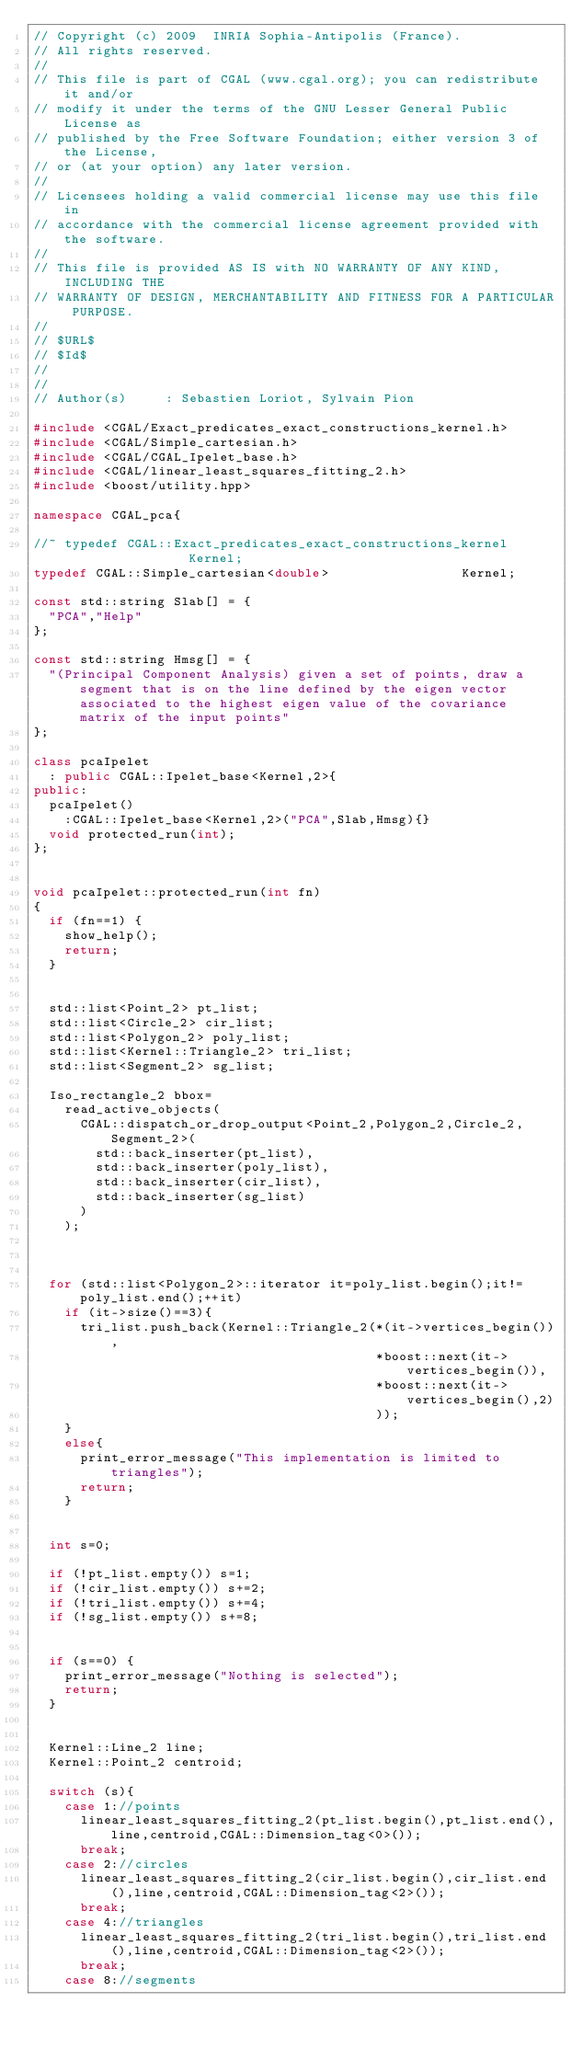Convert code to text. <code><loc_0><loc_0><loc_500><loc_500><_C++_>// Copyright (c) 2009  INRIA Sophia-Antipolis (France).
// All rights reserved.
//
// This file is part of CGAL (www.cgal.org); you can redistribute it and/or
// modify it under the terms of the GNU Lesser General Public License as
// published by the Free Software Foundation; either version 3 of the License,
// or (at your option) any later version.
//
// Licensees holding a valid commercial license may use this file in
// accordance with the commercial license agreement provided with the software.
//
// This file is provided AS IS with NO WARRANTY OF ANY KIND, INCLUDING THE
// WARRANTY OF DESIGN, MERCHANTABILITY AND FITNESS FOR A PARTICULAR PURPOSE.
//
// $URL$
// $Id$
// 
//
// Author(s)     : Sebastien Loriot, Sylvain Pion

#include <CGAL/Exact_predicates_exact_constructions_kernel.h>
#include <CGAL/Simple_cartesian.h>
#include <CGAL/CGAL_Ipelet_base.h> 
#include <CGAL/linear_least_squares_fitting_2.h>
#include <boost/utility.hpp>

namespace CGAL_pca{

//~ typedef CGAL::Exact_predicates_exact_constructions_kernel                 Kernel;
typedef CGAL::Simple_cartesian<double>                 Kernel;
  
const std::string Slab[] = {
  "PCA","Help"
};

const std::string Hmsg[] = {
  "(Principal Component Analysis) given a set of points, draw a segment that is on the line defined by the eigen vector associated to the highest eigen value of the covariance matrix of the input points"
};

class pcaIpelet 
  : public CGAL::Ipelet_base<Kernel,2>{
public:
  pcaIpelet()
    :CGAL::Ipelet_base<Kernel,2>("PCA",Slab,Hmsg){}
  void protected_run(int);
};


void pcaIpelet::protected_run(int fn)
{
  if (fn==1) {
    show_help();
    return;
  }

  
  std::list<Point_2> pt_list;
  std::list<Circle_2> cir_list;
  std::list<Polygon_2> poly_list;
  std::list<Kernel::Triangle_2> tri_list;
  std::list<Segment_2> sg_list;
  
  Iso_rectangle_2 bbox=
    read_active_objects(
      CGAL::dispatch_or_drop_output<Point_2,Polygon_2,Circle_2,Segment_2>(
        std::back_inserter(pt_list),
        std::back_inserter(poly_list),
        std::back_inserter(cir_list),
        std::back_inserter(sg_list)
      )
    );

  
  
  for (std::list<Polygon_2>::iterator it=poly_list.begin();it!=poly_list.end();++it)
    if (it->size()==3){
      tri_list.push_back(Kernel::Triangle_2(*(it->vertices_begin()),
                                            *boost::next(it->vertices_begin()),
                                            *boost::next(it->vertices_begin(),2)
                                            ));
    }
    else{
      print_error_message("This implementation is limited to triangles");
      return;          
    }
  
  
  int s=0;
  
  if (!pt_list.empty()) s=1;
  if (!cir_list.empty()) s+=2;
  if (!tri_list.empty()) s+=4;
  if (!sg_list.empty()) s+=8;
  
  
  if (s==0) {
    print_error_message("Nothing is selected");
    return;
  }
  
  
  Kernel::Line_2 line;
  Kernel::Point_2 centroid;
  
  switch (s){
    case 1://points
      linear_least_squares_fitting_2(pt_list.begin(),pt_list.end(),line,centroid,CGAL::Dimension_tag<0>());
      break;
    case 2://circles
      linear_least_squares_fitting_2(cir_list.begin(),cir_list.end(),line,centroid,CGAL::Dimension_tag<2>());
      break;
    case 4://triangles
      linear_least_squares_fitting_2(tri_list.begin(),tri_list.end(),line,centroid,CGAL::Dimension_tag<2>());
      break;
    case 8://segments</code> 